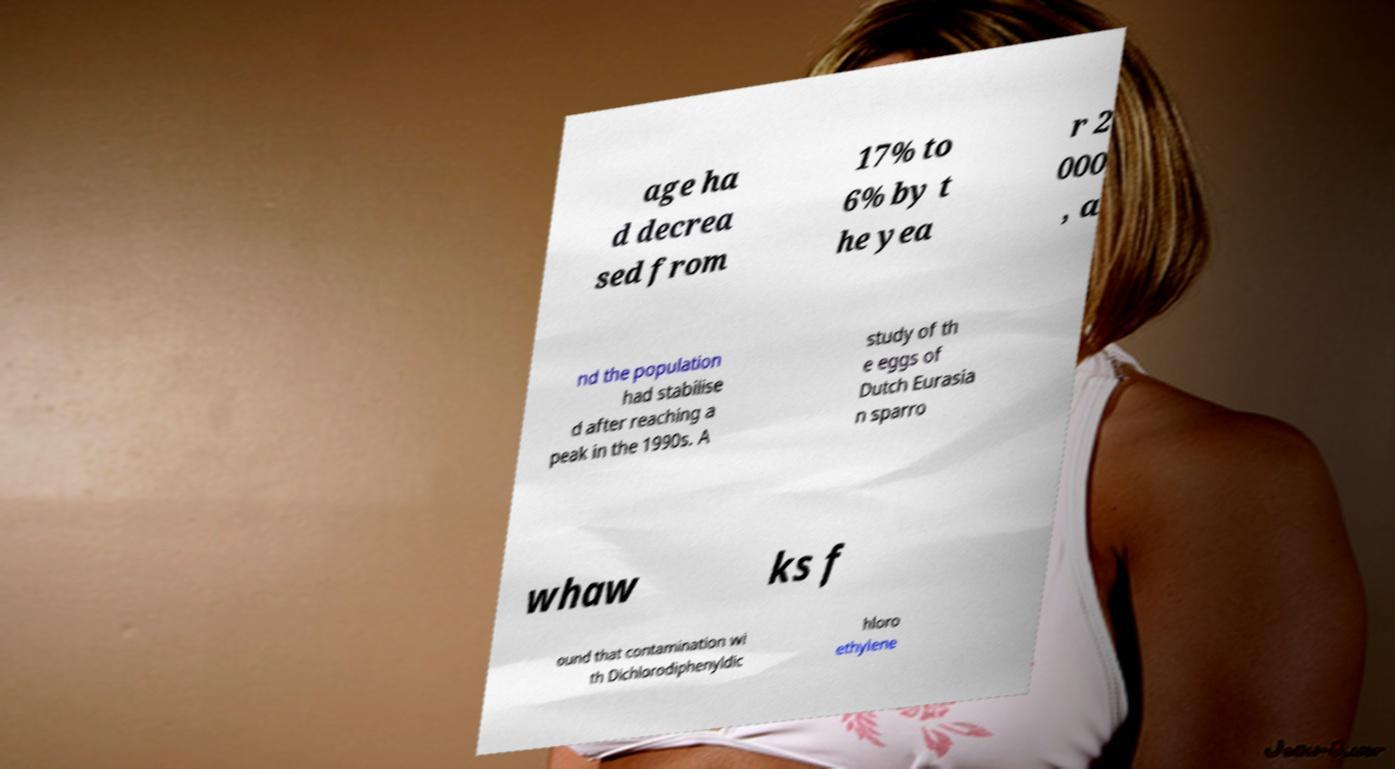I need the written content from this picture converted into text. Can you do that? age ha d decrea sed from 17% to 6% by t he yea r 2 000 , a nd the population had stabilise d after reaching a peak in the 1990s. A study of th e eggs of Dutch Eurasia n sparro whaw ks f ound that contamination wi th Dichlorodiphenyldic hloro ethylene 